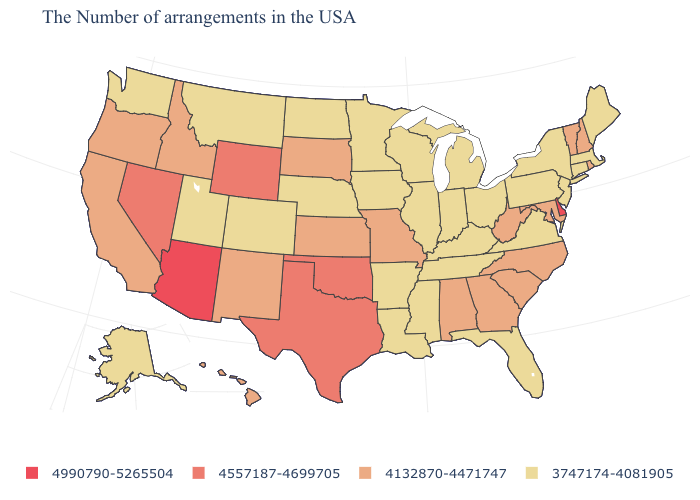What is the highest value in states that border Tennessee?
Concise answer only. 4132870-4471747. Which states have the lowest value in the USA?
Keep it brief. Maine, Massachusetts, Connecticut, New York, New Jersey, Pennsylvania, Virginia, Ohio, Florida, Michigan, Kentucky, Indiana, Tennessee, Wisconsin, Illinois, Mississippi, Louisiana, Arkansas, Minnesota, Iowa, Nebraska, North Dakota, Colorado, Utah, Montana, Washington, Alaska. Name the states that have a value in the range 4990790-5265504?
Be succinct. Delaware, Arizona. What is the highest value in the USA?
Be succinct. 4990790-5265504. Which states have the highest value in the USA?
Answer briefly. Delaware, Arizona. How many symbols are there in the legend?
Short answer required. 4. Among the states that border Connecticut , which have the lowest value?
Answer briefly. Massachusetts, New York. What is the highest value in the USA?
Keep it brief. 4990790-5265504. Does the first symbol in the legend represent the smallest category?
Concise answer only. No. What is the lowest value in the USA?
Answer briefly. 3747174-4081905. Which states hav the highest value in the South?
Answer briefly. Delaware. Which states hav the highest value in the MidWest?
Keep it brief. Missouri, Kansas, South Dakota. What is the value of Alabama?
Write a very short answer. 4132870-4471747. What is the value of Massachusetts?
Concise answer only. 3747174-4081905. What is the highest value in the USA?
Keep it brief. 4990790-5265504. 